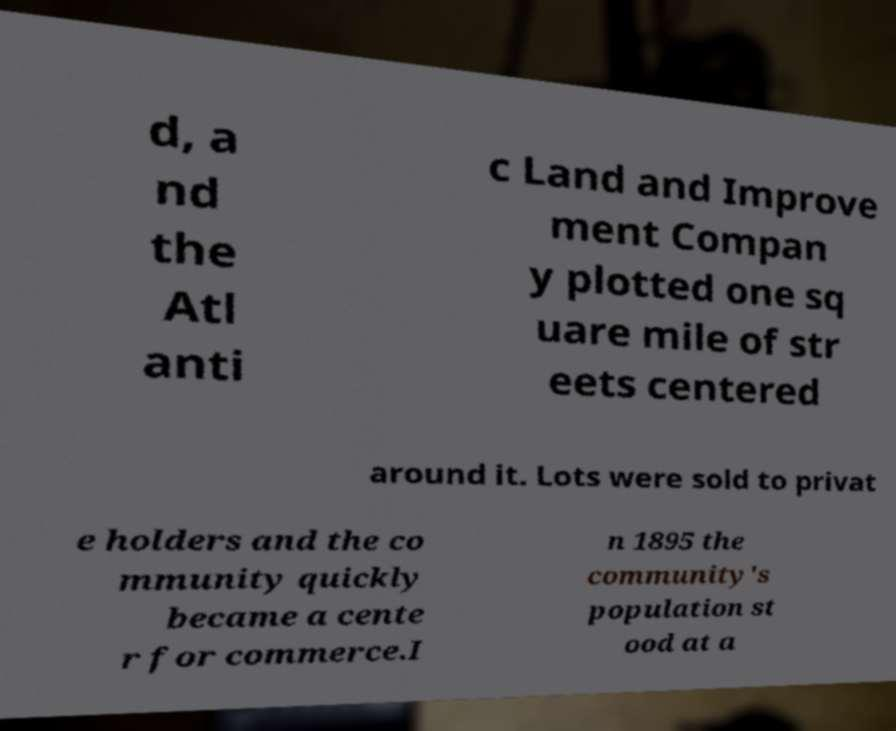What messages or text are displayed in this image? I need them in a readable, typed format. d, a nd the Atl anti c Land and Improve ment Compan y plotted one sq uare mile of str eets centered around it. Lots were sold to privat e holders and the co mmunity quickly became a cente r for commerce.I n 1895 the community's population st ood at a 